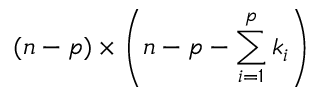<formula> <loc_0><loc_0><loc_500><loc_500>( n - p ) \times \left ( n - p - \sum _ { i = 1 } ^ { p } k _ { i } \right )</formula> 